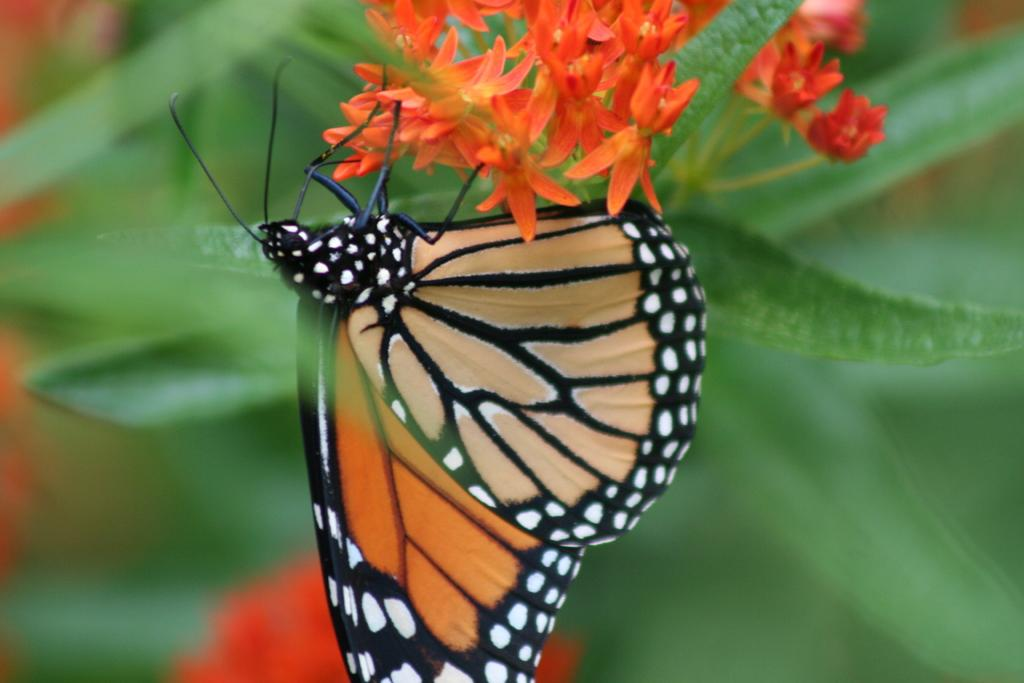What type of plants can be seen in the image? There are flowers and leaves in the image. Are there any animals present in the image? Yes, there is a butterfly in the image. How would you describe the background of the image? The background of the image is blurry. How many facts can be found in the image? The term "fact" refers to a piece of information, and the image itself is not composed of facts. However, the image does contain flowers, leaves, and a butterfly, which are observable details. 